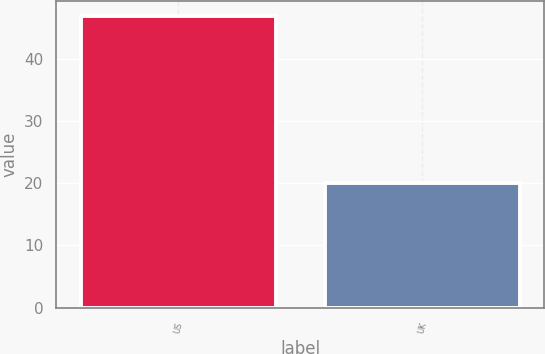<chart> <loc_0><loc_0><loc_500><loc_500><bar_chart><fcel>US<fcel>UK<nl><fcel>47<fcel>20<nl></chart> 